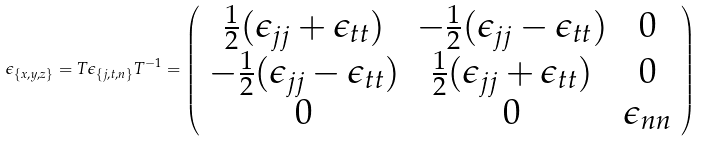Convert formula to latex. <formula><loc_0><loc_0><loc_500><loc_500>\epsilon _ { \left \{ x , y , z \right \} } = T \epsilon _ { \left \{ j , t , n \right \} } T ^ { - 1 } = \left ( \begin{array} { c c c } \frac { 1 } { 2 } ( \epsilon _ { j j } + \epsilon _ { t t } ) & - \frac { 1 } { 2 } ( \epsilon _ { j j } - \epsilon _ { t t } ) & 0 \\ - \frac { 1 } { 2 } ( \epsilon _ { j j } - \epsilon _ { t t } ) & \frac { 1 } { 2 } ( \epsilon _ { j j } + \epsilon _ { t t } ) & 0 \\ 0 & 0 & \epsilon _ { n n } \\ \end{array} \right )</formula> 